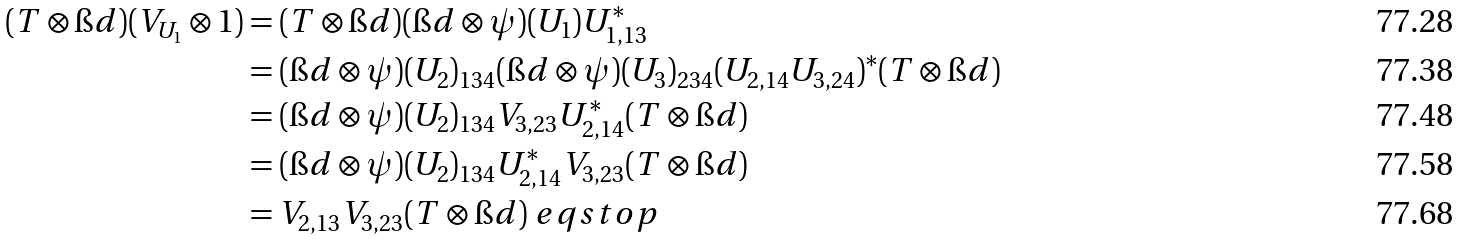Convert formula to latex. <formula><loc_0><loc_0><loc_500><loc_500>( T \otimes \i d ) ( V _ { U _ { 1 } } \otimes 1 ) & = ( T \otimes \i d ) ( \i d \otimes \psi ) ( U _ { 1 } ) U _ { 1 , 1 3 } ^ { * } \\ & = ( \i d \otimes \psi ) ( U _ { 2 } ) _ { 1 3 4 } ( \i d \otimes \psi ) ( U _ { 3 } ) _ { 2 3 4 } ( U _ { 2 , 1 4 } U _ { 3 , 2 4 } ) ^ { * } ( T \otimes \i d ) \\ & = ( \i d \otimes \psi ) ( U _ { 2 } ) _ { 1 3 4 } V _ { 3 , 2 3 } U _ { 2 , 1 4 } ^ { * } ( T \otimes \i d ) \\ & = ( \i d \otimes \psi ) ( U _ { 2 } ) _ { 1 3 4 } U _ { 2 , 1 4 } ^ { * } V _ { 3 , 2 3 } ( T \otimes \i d ) \\ & = V _ { 2 , 1 3 } V _ { 3 , 2 3 } ( T \otimes \i d ) \ e q s t o p</formula> 